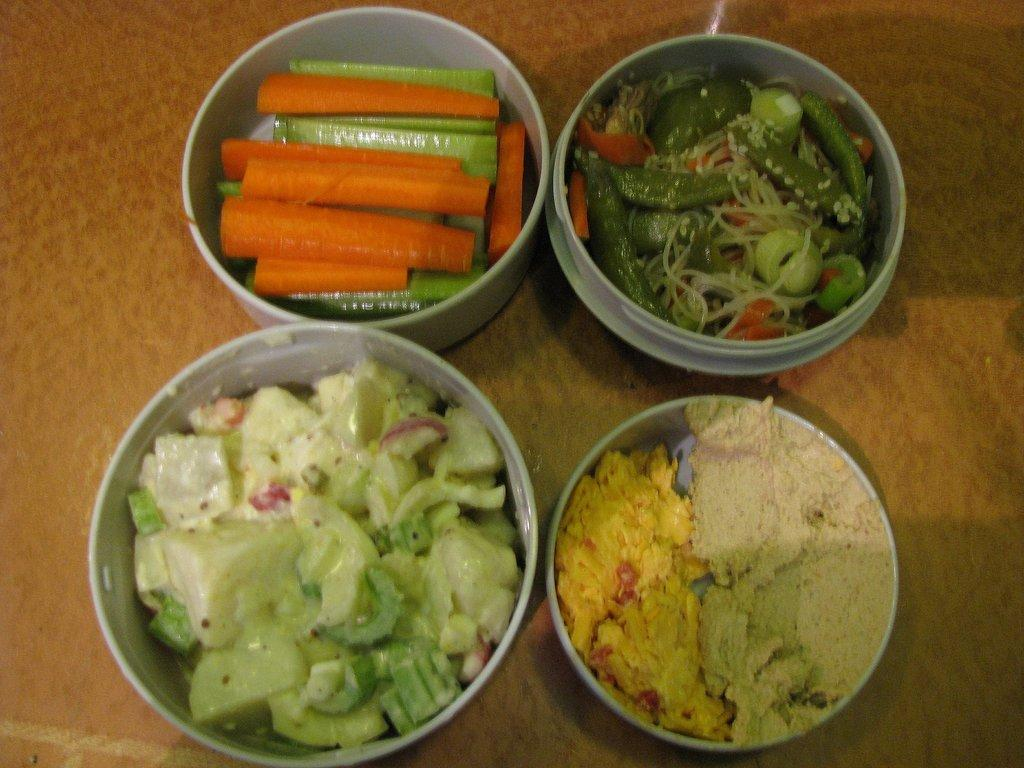How many bowls with food items are visible in the image? There are three bowls with food items in the image. What type of food item can be found in one of the bowls? There is a bowl with vegetables in the image. How many friends are visible in the image? There are no friends visible in the image; it only shows three bowls with food items. What type of connection can be seen between the bowls in the image? There is no visible connection between the bowls in the image; they are simply placed next to each other. 